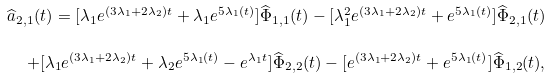<formula> <loc_0><loc_0><loc_500><loc_500>\widehat { a } _ { 2 , 1 } ( t ) = [ \lambda _ { 1 } e ^ { ( 3 \lambda _ { 1 } + 2 \lambda _ { 2 } ) t } + \lambda _ { 1 } e ^ { 5 \lambda _ { 1 } ( t ) } ] \widehat { \Phi } _ { 1 , 1 } ( t ) - [ \lambda ^ { 2 } _ { 1 } e ^ { ( 3 \lambda _ { 1 } + 2 \lambda _ { 2 } ) t } + e ^ { 5 \lambda _ { 1 } ( t ) } ] \widehat { \Phi } _ { 2 , 1 } ( t ) & \\ + [ \lambda _ { 1 } e ^ { ( 3 \lambda _ { 1 } + 2 \lambda _ { 2 } ) t } + \lambda _ { 2 } e ^ { 5 \lambda _ { 1 } ( t ) } - e ^ { \lambda _ { 1 } t } ] \widehat { \Phi } _ { 2 , 2 } ( t ) - [ e ^ { ( 3 \lambda _ { 1 } + 2 \lambda _ { 2 } ) t } + e ^ { 5 \lambda _ { 1 } ( t ) } ] \widehat { \Phi } _ { 1 , 2 } ( t ) ,</formula> 